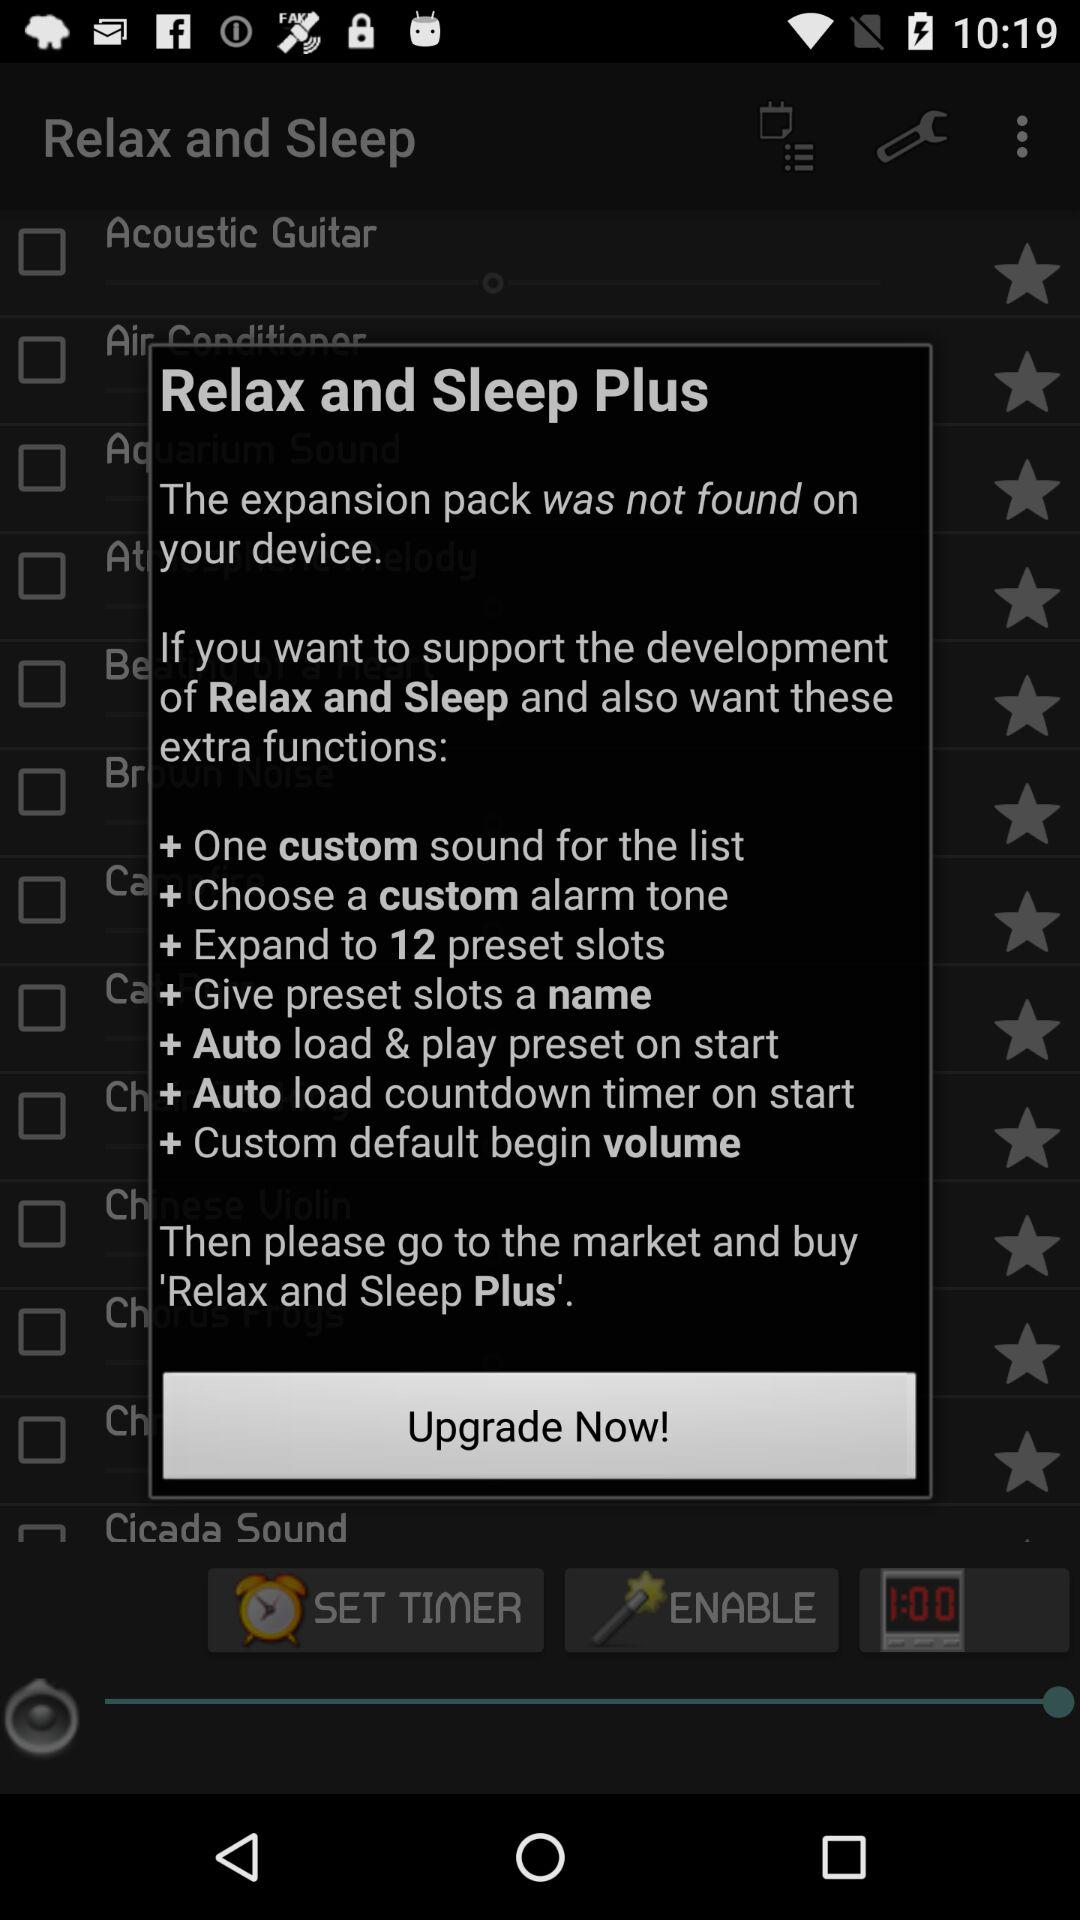What are the different functions of the "Relax and Sleep Plus"? The different functions are "One custom sound for the list", "Choose a custom alarm tone", "Expand to 12 preset slots", "Give preset slots a name", "Auto load & play preset on start", "Auto load countdown timer on start" and "Custom default begin volume". 